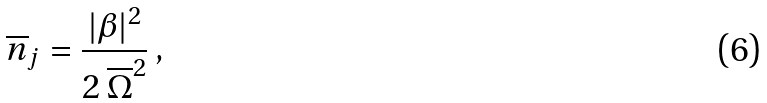Convert formula to latex. <formula><loc_0><loc_0><loc_500><loc_500>\overline { n } _ { j } = \frac { | \beta | ^ { 2 } } { 2 \, { \overline { \Omega } } ^ { 2 } } \, ,</formula> 